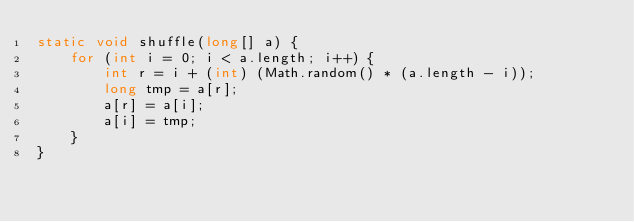<code> <loc_0><loc_0><loc_500><loc_500><_Java_>static void shuffle(long[] a) {
    for (int i = 0; i < a.length; i++) {
        int r = i + (int) (Math.random() * (a.length - i));
        long tmp = a[r];
        a[r] = a[i];
        a[i] = tmp;
    }
}</code> 